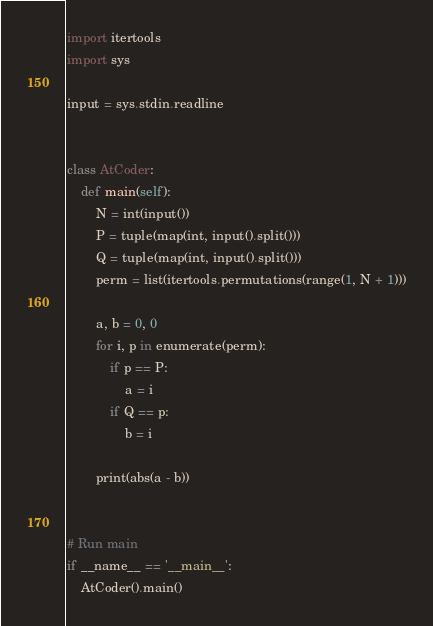<code> <loc_0><loc_0><loc_500><loc_500><_Python_>import itertools
import sys

input = sys.stdin.readline


class AtCoder:
    def main(self):
        N = int(input())
        P = tuple(map(int, input().split()))
        Q = tuple(map(int, input().split()))
        perm = list(itertools.permutations(range(1, N + 1)))

        a, b = 0, 0
        for i, p in enumerate(perm):
            if p == P:
                a = i
            if Q == p:
                b = i

        print(abs(a - b))


# Run main
if __name__ == '__main__':
    AtCoder().main()
</code> 